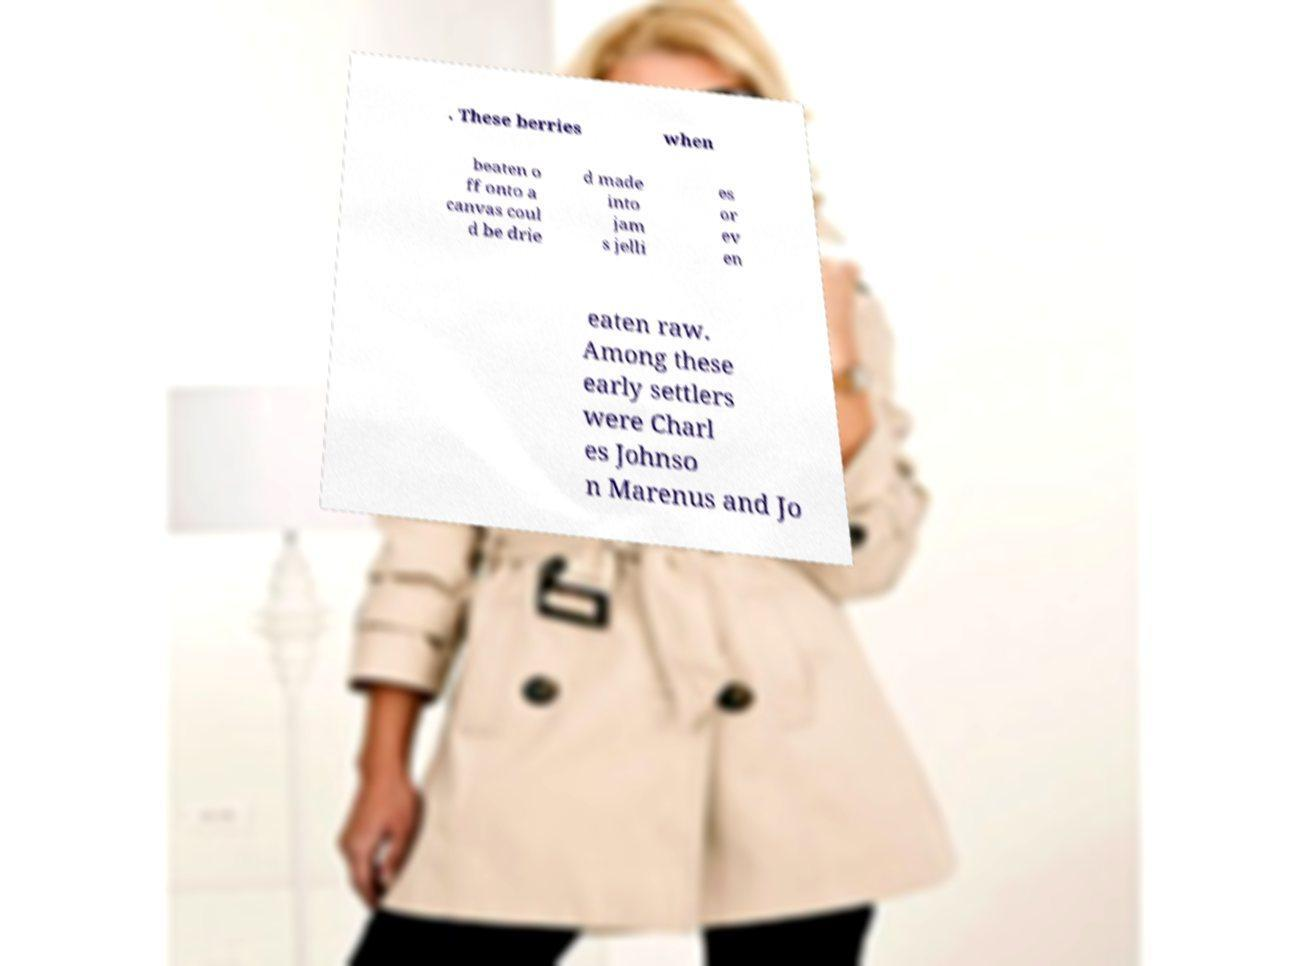Can you read and provide the text displayed in the image?This photo seems to have some interesting text. Can you extract and type it out for me? . These berries when beaten o ff onto a canvas coul d be drie d made into jam s jelli es or ev en eaten raw. Among these early settlers were Charl es Johnso n Marenus and Jo 